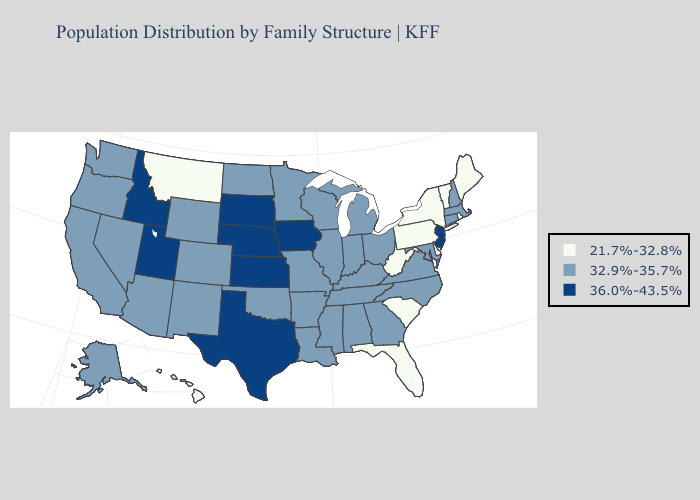Does Vermont have the same value as Montana?
Concise answer only. Yes. What is the highest value in states that border Idaho?
Concise answer only. 36.0%-43.5%. What is the highest value in the South ?
Concise answer only. 36.0%-43.5%. Does Montana have the highest value in the USA?
Quick response, please. No. What is the highest value in the USA?
Short answer required. 36.0%-43.5%. Does the first symbol in the legend represent the smallest category?
Short answer required. Yes. What is the value of Oregon?
Write a very short answer. 32.9%-35.7%. Does Arkansas have a higher value than Illinois?
Give a very brief answer. No. Name the states that have a value in the range 36.0%-43.5%?
Answer briefly. Idaho, Iowa, Kansas, Nebraska, New Jersey, South Dakota, Texas, Utah. What is the lowest value in the USA?
Give a very brief answer. 21.7%-32.8%. Does Massachusetts have a higher value than Louisiana?
Concise answer only. No. Which states hav the highest value in the West?
Short answer required. Idaho, Utah. Which states have the lowest value in the MidWest?
Concise answer only. Illinois, Indiana, Michigan, Minnesota, Missouri, North Dakota, Ohio, Wisconsin. What is the value of Virginia?
Be succinct. 32.9%-35.7%. Does Utah have a higher value than Illinois?
Answer briefly. Yes. 